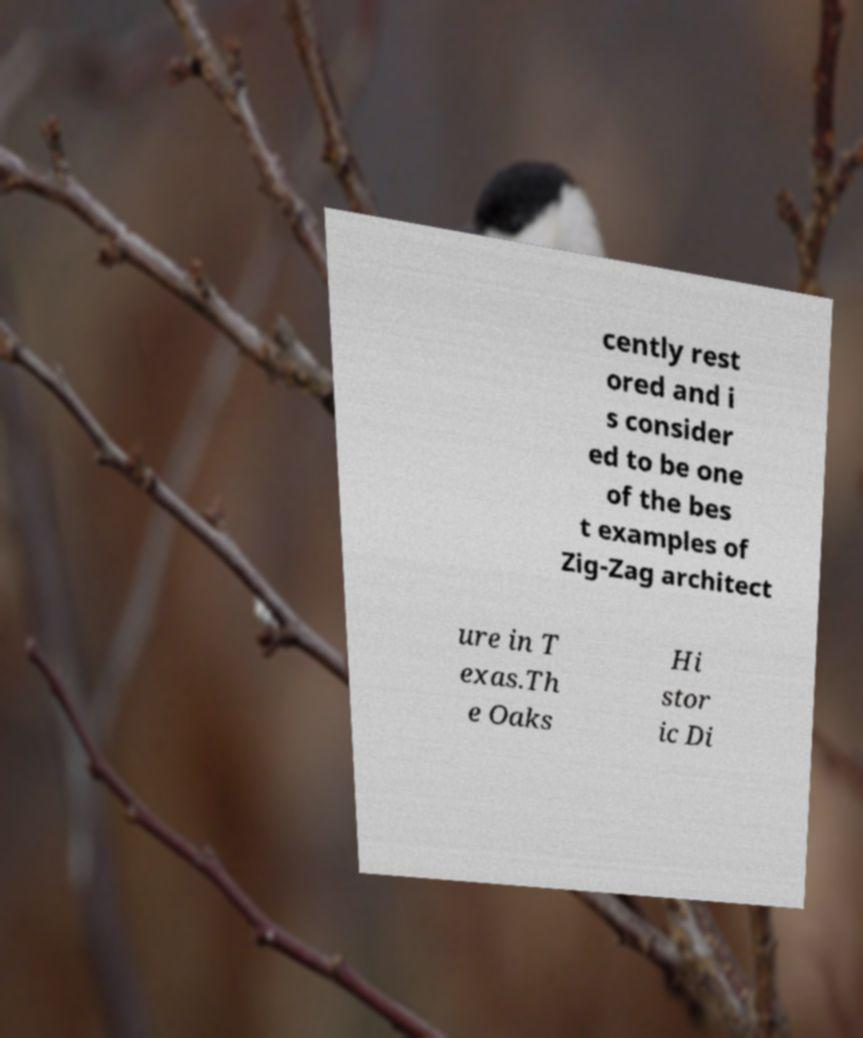For documentation purposes, I need the text within this image transcribed. Could you provide that? cently rest ored and i s consider ed to be one of the bes t examples of Zig-Zag architect ure in T exas.Th e Oaks Hi stor ic Di 